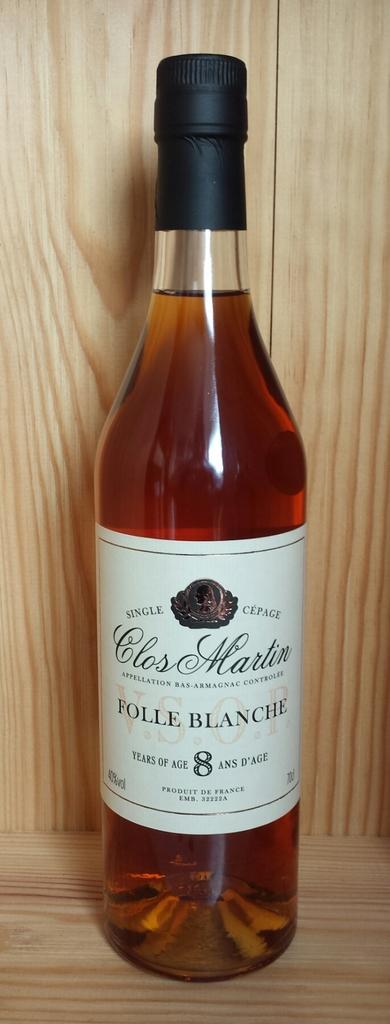What is the type of wine?
Your response must be concise. Folle blanche. What is the name of the wine?
Your response must be concise. Rolle blanche. 